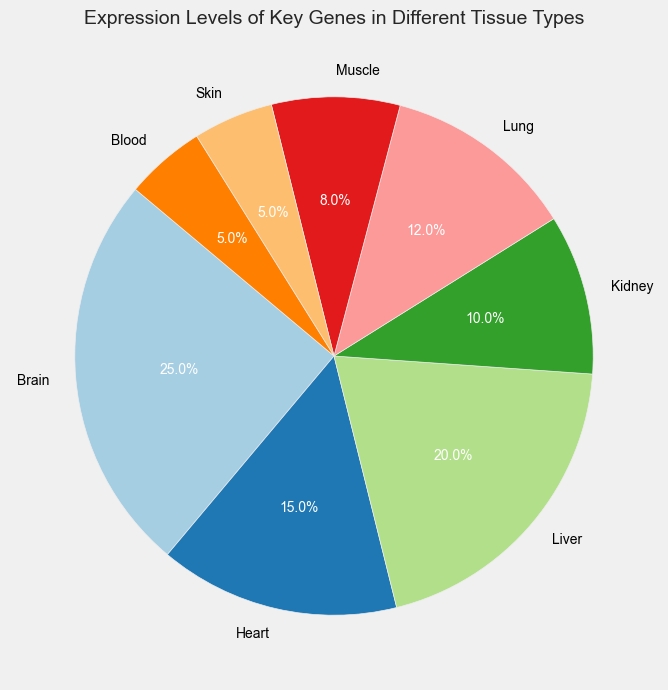Which tissue type has the highest expression level? Look at the pie chart and identify the tissue type with the largest section. The Brain has the largest section indicating it has the highest expression level.
Answer: Brain Which tissue types have the same expression level? Identify tissues with equally sized sections. Both Skin and Blood have the same size sections indicating the same expression level.
Answer: Skin and Blood What is the combined expression level percentage of Brain and Liver tissues? Look at the Brain and Liver sections and sum up their percentages. The Brain is 25% and Liver is 20%, so 25% + 20% = 45%.
Answer: 45% Which tissue type has a lower expression level than Lung but higher than Muscle? Identify the Lung and Muscle sections to see their sizes and find the section between them. Kidney's section falls between Lung and Muscle, so it has a lower expression level than Lung but higher than Muscle.
Answer: Kidney How does the expression level of Heart compare to that of Kidney? Check the sizes of the Heart and Kidney sections. The Heart section is larger, indicating a higher expression level.
Answer: Higher Which tissue types together contribute to half of the total expression level? Summarize the consecutive sections starting from the largest until the combined percentage is around 50%. Brain (25%) and Liver (20%) together contribute 25% + 20% = 45%, but adding Heart (15%) would go beyond half. Brain (25%), Liver (20%), and Heart (15%).
Answer: Brain, Liver Which tissue type has the smallest expression level? Identify the smallest section on the pie chart. The smallest section corresponds to Blood (or Skin since they have the same expression level).
Answer: Blood What is the combined expression level of the tissues with the lowest and highest expression levels? Identify and sum the highest and lowest percentages. The highest is Brain (25%), and the lowest is Blood (or Skin) (5%). 25% + 5% = 30%.
Answer: 30% Which tissue type has the second highest expression level? Identify the section size just below the largest one. Liver is the second largest after Brain.
Answer: Liver How does the expression level of Lung compare to the sum of Muscle and Skin expression levels? Identify and compare the section sizes. Lung has 12%, while Muscle and Skin together have 8% + 5% = 13%. 12% < 13%.
Answer: Lower 